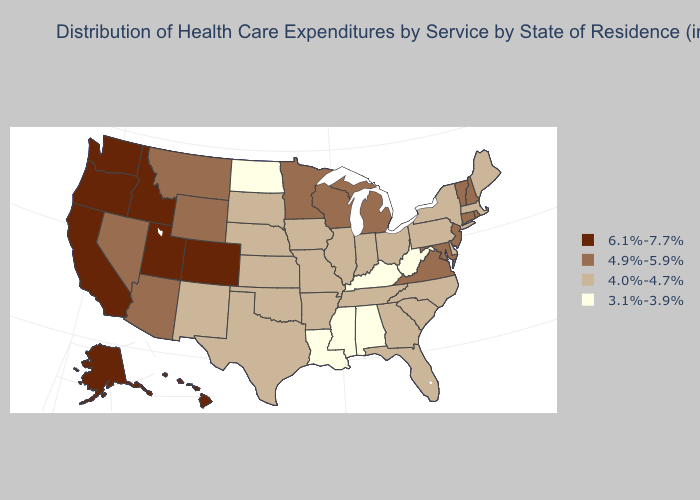Which states have the lowest value in the USA?
Give a very brief answer. Alabama, Kentucky, Louisiana, Mississippi, North Dakota, West Virginia. Does the map have missing data?
Short answer required. No. Does the first symbol in the legend represent the smallest category?
Write a very short answer. No. Does Alaska have a lower value than Utah?
Quick response, please. No. Name the states that have a value in the range 4.9%-5.9%?
Write a very short answer. Arizona, Connecticut, Maryland, Michigan, Minnesota, Montana, Nevada, New Hampshire, New Jersey, Rhode Island, Vermont, Virginia, Wisconsin, Wyoming. How many symbols are there in the legend?
Write a very short answer. 4. What is the value of Kansas?
Write a very short answer. 4.0%-4.7%. What is the value of Arkansas?
Be succinct. 4.0%-4.7%. Does the map have missing data?
Short answer required. No. Does North Carolina have the highest value in the USA?
Short answer required. No. Does Ohio have a higher value than Rhode Island?
Give a very brief answer. No. What is the lowest value in the West?
Short answer required. 4.0%-4.7%. Among the states that border Colorado , does Nebraska have the lowest value?
Short answer required. Yes. Does the map have missing data?
Short answer required. No. Name the states that have a value in the range 4.9%-5.9%?
Write a very short answer. Arizona, Connecticut, Maryland, Michigan, Minnesota, Montana, Nevada, New Hampshire, New Jersey, Rhode Island, Vermont, Virginia, Wisconsin, Wyoming. 